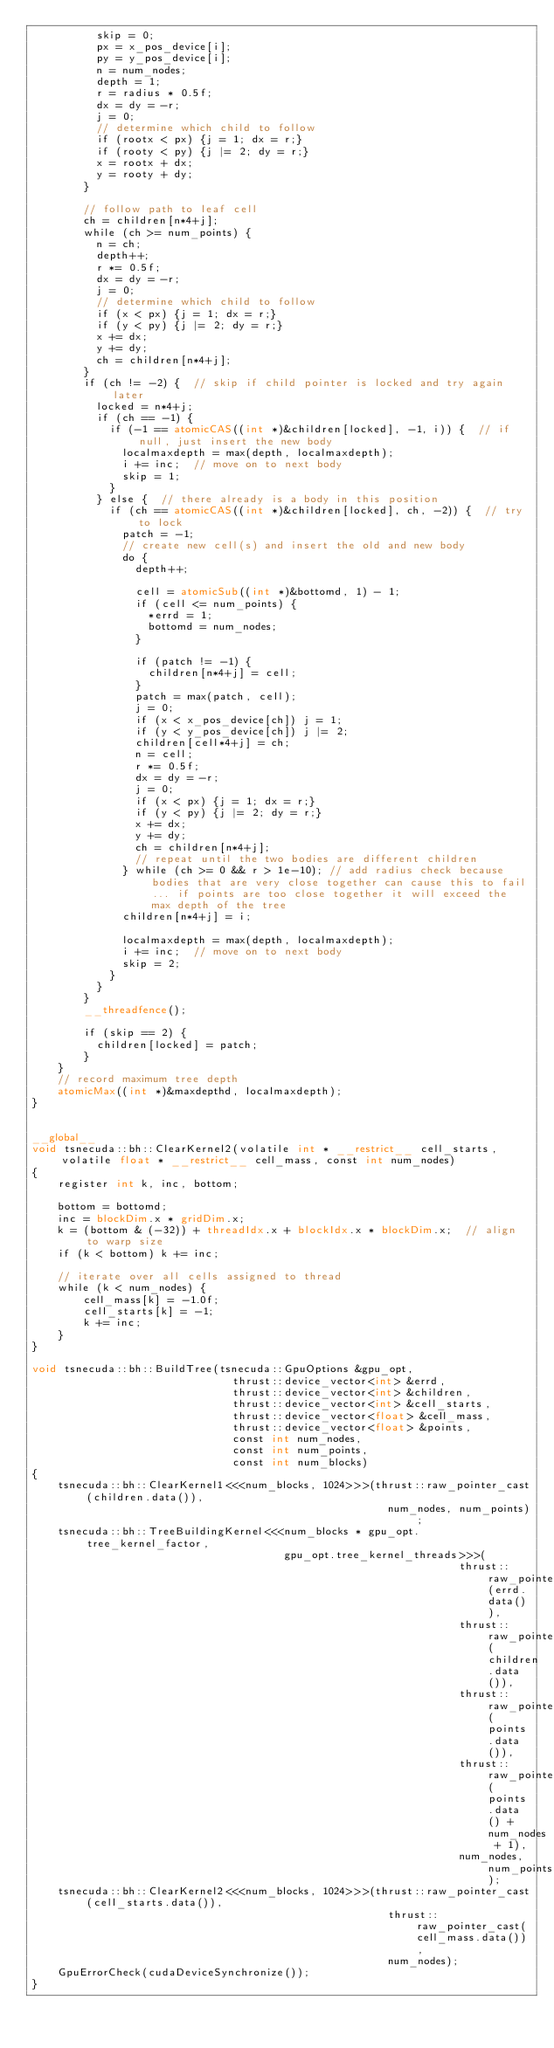Convert code to text. <code><loc_0><loc_0><loc_500><loc_500><_Cuda_>          skip = 0;
          px = x_pos_device[i];
          py = y_pos_device[i];
          n = num_nodes;
          depth = 1;
          r = radius * 0.5f;
          dx = dy = -r;
          j = 0;
          // determine which child to follow
          if (rootx < px) {j = 1; dx = r;}
          if (rooty < py) {j |= 2; dy = r;}
          x = rootx + dx;
          y = rooty + dy;
        }

        // follow path to leaf cell
        ch = children[n*4+j];
        while (ch >= num_points) {
          n = ch;
          depth++;
          r *= 0.5f;
          dx = dy = -r;
          j = 0;
          // determine which child to follow
          if (x < px) {j = 1; dx = r;}
          if (y < py) {j |= 2; dy = r;}
          x += dx;
          y += dy;
          ch = children[n*4+j];
        }
        if (ch != -2) {  // skip if child pointer is locked and try again later
          locked = n*4+j;
          if (ch == -1) {
            if (-1 == atomicCAS((int *)&children[locked], -1, i)) {  // if null, just insert the new body
              localmaxdepth = max(depth, localmaxdepth);
              i += inc;  // move on to next body
              skip = 1;
            }
          } else {  // there already is a body in this position
            if (ch == atomicCAS((int *)&children[locked], ch, -2)) {  // try to lock
              patch = -1;
              // create new cell(s) and insert the old and new body
              do {
                depth++;

                cell = atomicSub((int *)&bottomd, 1) - 1;
                if (cell <= num_points) {
                  *errd = 1;
                  bottomd = num_nodes;
                }

                if (patch != -1) {
                  children[n*4+j] = cell;
                }
                patch = max(patch, cell);
                j = 0;
                if (x < x_pos_device[ch]) j = 1;
                if (y < y_pos_device[ch]) j |= 2;
                children[cell*4+j] = ch;
                n = cell;
                r *= 0.5f;
                dx = dy = -r;
                j = 0;
                if (x < px) {j = 1; dx = r;}
                if (y < py) {j |= 2; dy = r;}
                x += dx;
                y += dy;
                ch = children[n*4+j];
                // repeat until the two bodies are different children
              } while (ch >= 0 && r > 1e-10); // add radius check because bodies that are very close together can cause this to fail... if points are too close together it will exceed the max depth of the tree 
              children[n*4+j] = i;

              localmaxdepth = max(depth, localmaxdepth);
              i += inc;  // move on to next body
              skip = 2;
            }
          }
        }
        __threadfence();

        if (skip == 2) {
          children[locked] = patch;
        }
    }
    // record maximum tree depth
    atomicMax((int *)&maxdepthd, localmaxdepth);
}


__global__
void tsnecuda::bh::ClearKernel2(volatile int * __restrict__ cell_starts, volatile float * __restrict__ cell_mass, const int num_nodes)
{
    register int k, inc, bottom;

    bottom = bottomd;
    inc = blockDim.x * gridDim.x;
    k = (bottom & (-32)) + threadIdx.x + blockIdx.x * blockDim.x;  // align to warp size
    if (k < bottom) k += inc;

    // iterate over all cells assigned to thread
    while (k < num_nodes) {
        cell_mass[k] = -1.0f;
        cell_starts[k] = -1;
        k += inc;
    }
}

void tsnecuda::bh::BuildTree(tsnecuda::GpuOptions &gpu_opt,
                               thrust::device_vector<int> &errd,
                               thrust::device_vector<int> &children,
                               thrust::device_vector<int> &cell_starts,
                               thrust::device_vector<float> &cell_mass,
                               thrust::device_vector<float> &points,
                               const int num_nodes,
                               const int num_points,
                               const int num_blocks)
{
    tsnecuda::bh::ClearKernel1<<<num_blocks, 1024>>>(thrust::raw_pointer_cast(children.data()),
                                                       num_nodes, num_points);
    tsnecuda::bh::TreeBuildingKernel<<<num_blocks * gpu_opt.tree_kernel_factor,
                                       gpu_opt.tree_kernel_threads>>>(
                                                                  thrust::raw_pointer_cast(errd.data()),
                                                                  thrust::raw_pointer_cast(children.data()),
                                                                  thrust::raw_pointer_cast(points.data()),
                                                                  thrust::raw_pointer_cast(points.data() + num_nodes + 1),
                                                                  num_nodes, num_points);
    tsnecuda::bh::ClearKernel2<<<num_blocks, 1024>>>(thrust::raw_pointer_cast(cell_starts.data()),
                                                       thrust::raw_pointer_cast(cell_mass.data()),
                                                       num_nodes);
    GpuErrorCheck(cudaDeviceSynchronize());
}
</code> 